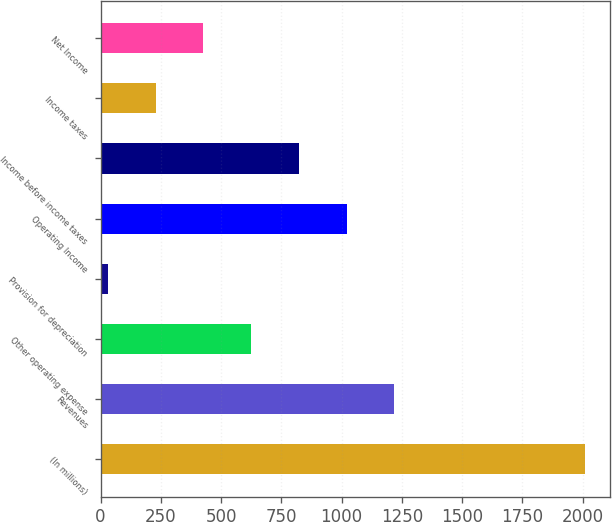Convert chart to OTSL. <chart><loc_0><loc_0><loc_500><loc_500><bar_chart><fcel>(In millions)<fcel>Revenues<fcel>Other operating expense<fcel>Provision for depreciation<fcel>Operating Income<fcel>Income before income taxes<fcel>Income taxes<fcel>Net Income<nl><fcel>2011<fcel>1219<fcel>625<fcel>31<fcel>1021<fcel>823<fcel>229<fcel>427<nl></chart> 